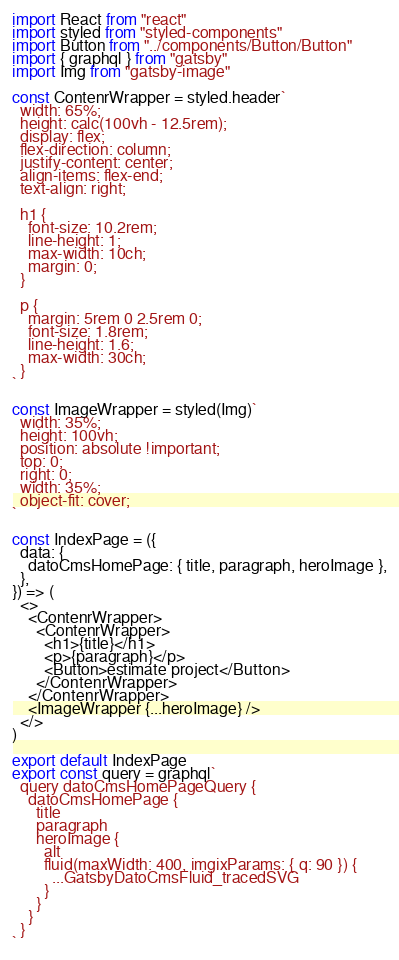<code> <loc_0><loc_0><loc_500><loc_500><_JavaScript_>import React from "react"
import styled from "styled-components"
import Button from "../components/Button/Button"
import { graphql } from "gatsby"
import Img from "gatsby-image"

const ContenrWrapper = styled.header`
  width: 65%;
  height: calc(100vh - 12.5rem);
  display: flex;
  flex-direction: column;
  justify-content: center;
  align-items: flex-end;
  text-align: right;

  h1 {
    font-size: 10.2rem;
    line-height: 1;
    max-width: 10ch;
    margin: 0;
  }

  p {
    margin: 5rem 0 2.5rem 0;
    font-size: 1.8rem;
    line-height: 1.6;
    max-width: 30ch;
  }
`

const ImageWrapper = styled(Img)`
  width: 35%;
  height: 100vh;
  position: absolute !important;
  top: 0;
  right: 0;
  width: 35%;
  object-fit: cover;
`

const IndexPage = ({
  data: {
    datoCmsHomePage: { title, paragraph, heroImage },
  },
}) => (
  <>
    <ContenrWrapper>
      <ContenrWrapper>
        <h1>{title}</h1>
        <p>{paragraph}</p>
        <Button>estimate project</Button>
      </ContenrWrapper>
    </ContenrWrapper>
    <ImageWrapper {...heroImage} />
  </>
)

export default IndexPage
export const query = graphql`
  query datoCmsHomePageQuery {
    datoCmsHomePage {
      title
      paragraph
      heroImage {
        alt
        fluid(maxWidth: 400, imgixParams: { q: 90 }) {
          ...GatsbyDatoCmsFluid_tracedSVG
        }
      }
    }
  }
`
</code> 